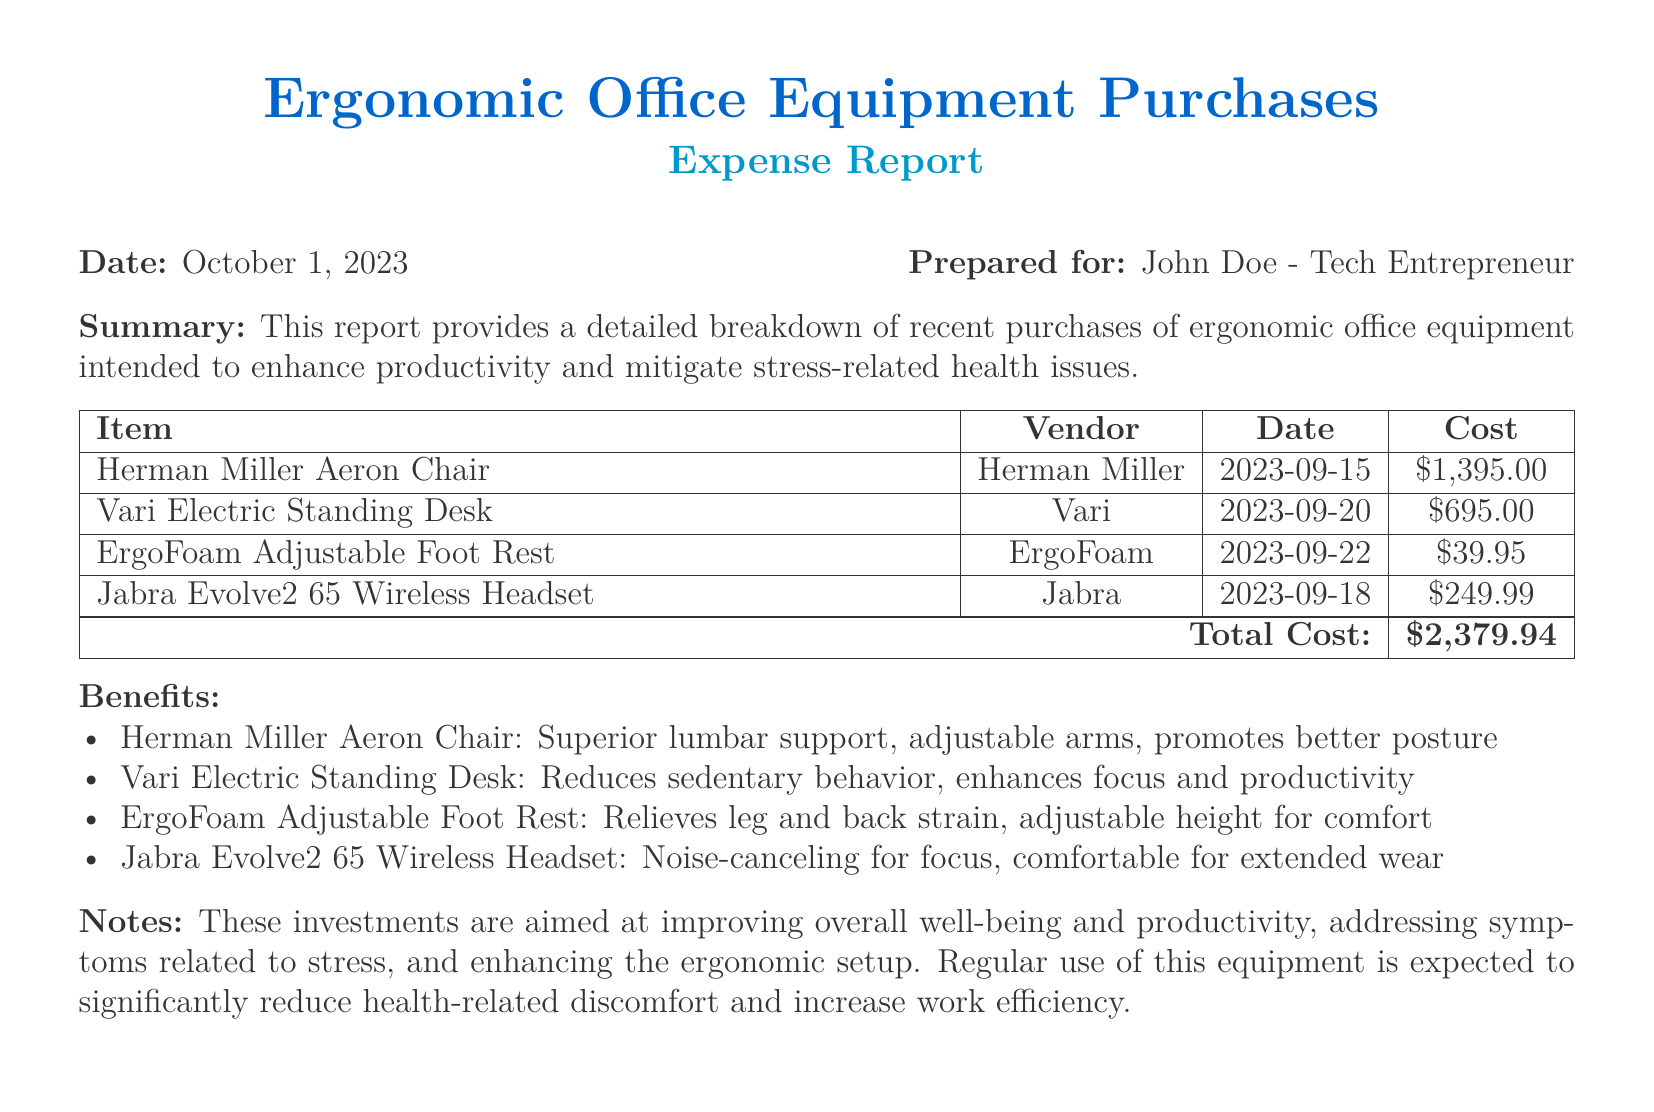what is the total cost of the purchases? The total cost is listed at the bottom of the expense report as the sum of all equipment costs.
Answer: $2,379.94 who is the report prepared for? The report specifies the name of the individual it is prepared for at the top.
Answer: John Doe what is the date of the report? The date is mentioned at the beginning of the document right after the title.
Answer: October 1, 2023 which vendor sold the Hermann Miller Aeron Chair? The vendor for this specific item is stated in the tabular section of the report.
Answer: Herman Miller what is one benefit of the Vari Electric Standing Desk? The benefits of each item are listed under their respective headings; reasoning can be applied by referring to that section.
Answer: Reduces sedentary behavior how many items are listed in the report? By counting the entries in the table, we can determine the number of items listed.
Answer: 4 what is the purchase date of the Jabra Evolve2 65 Wireless Headset? The document lists specific purchase dates in the tabular section.
Answer: 2023-09-18 what is one feature of the ErgoFoam Adjustable Foot Rest? Each item benefits are described in a bullet list, which includes specific features of the footrest.
Answer: Relieves leg and back strain what type of document is this? The title and format indicate the nature of the document.
Answer: Expense report 